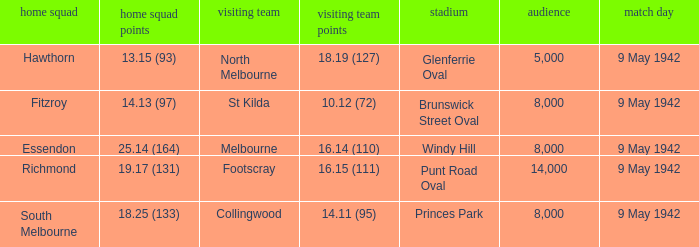How many people attended the game with the home team scoring 18.25 (133)? 1.0. 